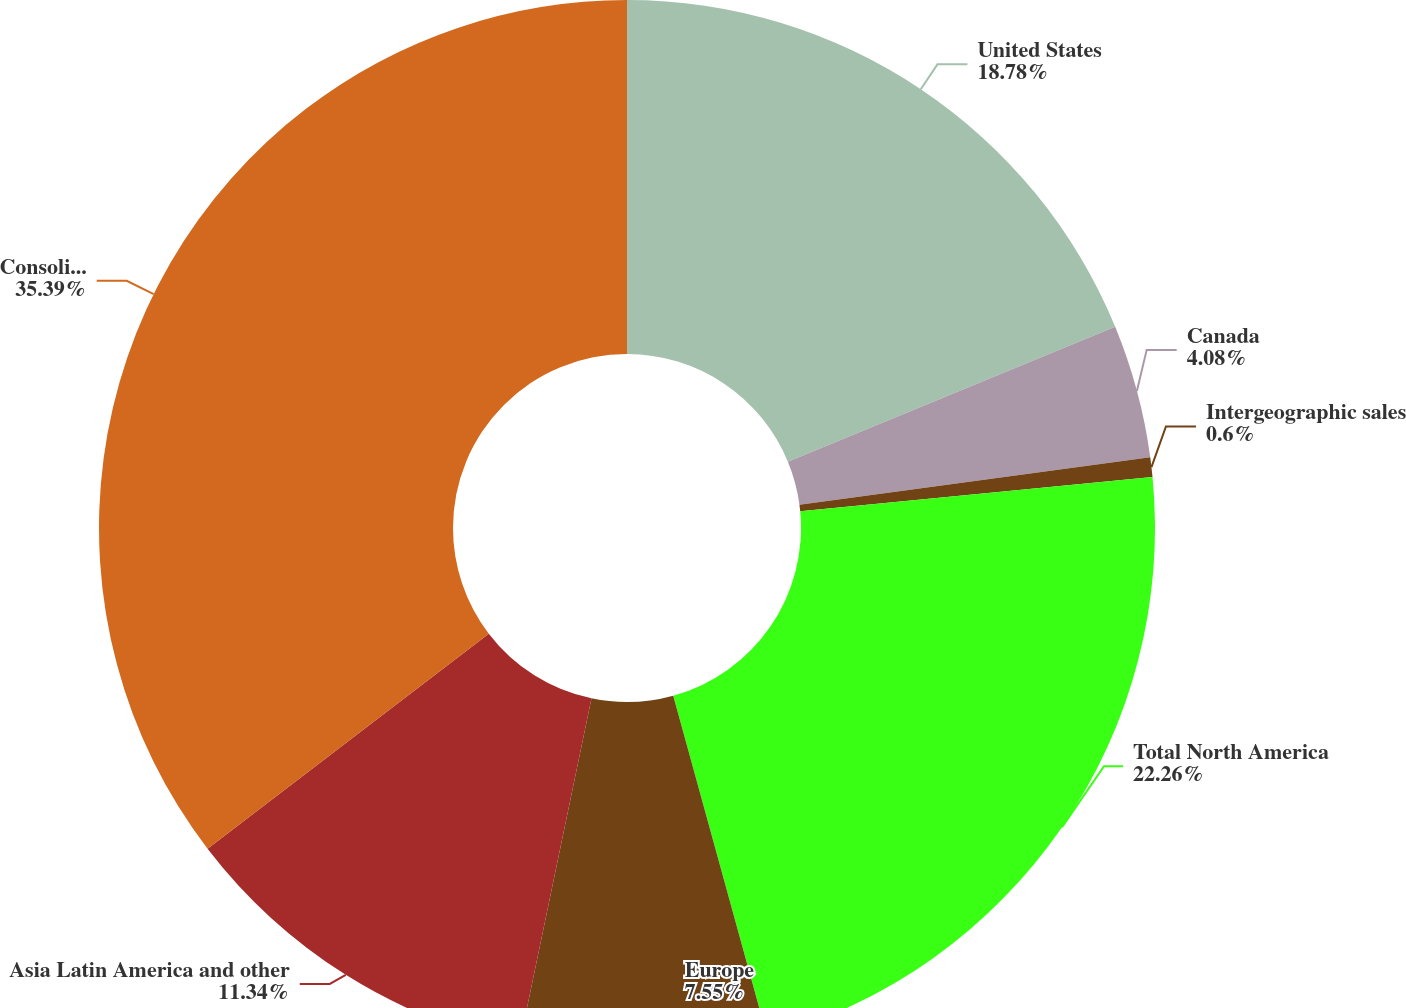<chart> <loc_0><loc_0><loc_500><loc_500><pie_chart><fcel>United States<fcel>Canada<fcel>Intergeographic sales<fcel>Total North America<fcel>Europe<fcel>Asia Latin America and other<fcel>Consolidated<nl><fcel>18.78%<fcel>4.08%<fcel>0.6%<fcel>22.26%<fcel>7.55%<fcel>11.34%<fcel>35.39%<nl></chart> 